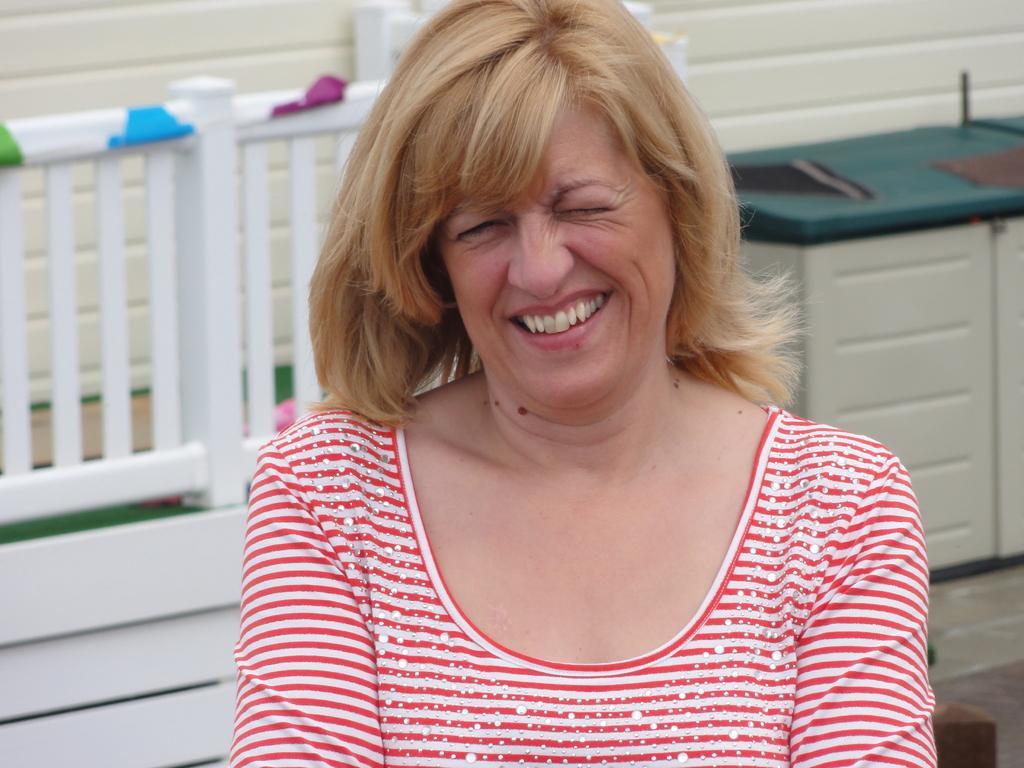Can you describe this image briefly? In this picture I can see there is a woman sitting on a white bench and she is laughing and she is wearing a red and white shirt and there is a wall in the backdrop and there is a box on right side. 